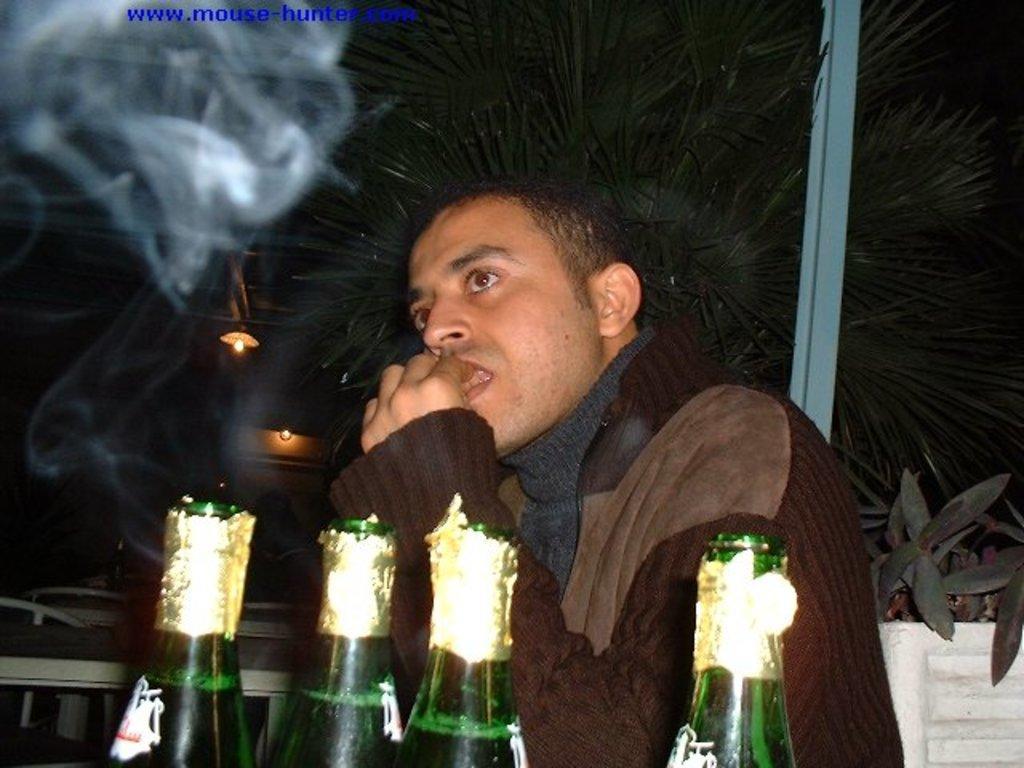How would you summarize this image in a sentence or two? There is a man in the image and there are four bottles on the tables. At the back there are tables and chairs. At the top there are lights and there is a tree behind the man. 